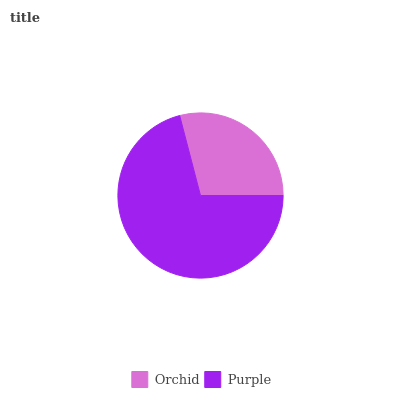Is Orchid the minimum?
Answer yes or no. Yes. Is Purple the maximum?
Answer yes or no. Yes. Is Purple the minimum?
Answer yes or no. No. Is Purple greater than Orchid?
Answer yes or no. Yes. Is Orchid less than Purple?
Answer yes or no. Yes. Is Orchid greater than Purple?
Answer yes or no. No. Is Purple less than Orchid?
Answer yes or no. No. Is Purple the high median?
Answer yes or no. Yes. Is Orchid the low median?
Answer yes or no. Yes. Is Orchid the high median?
Answer yes or no. No. Is Purple the low median?
Answer yes or no. No. 